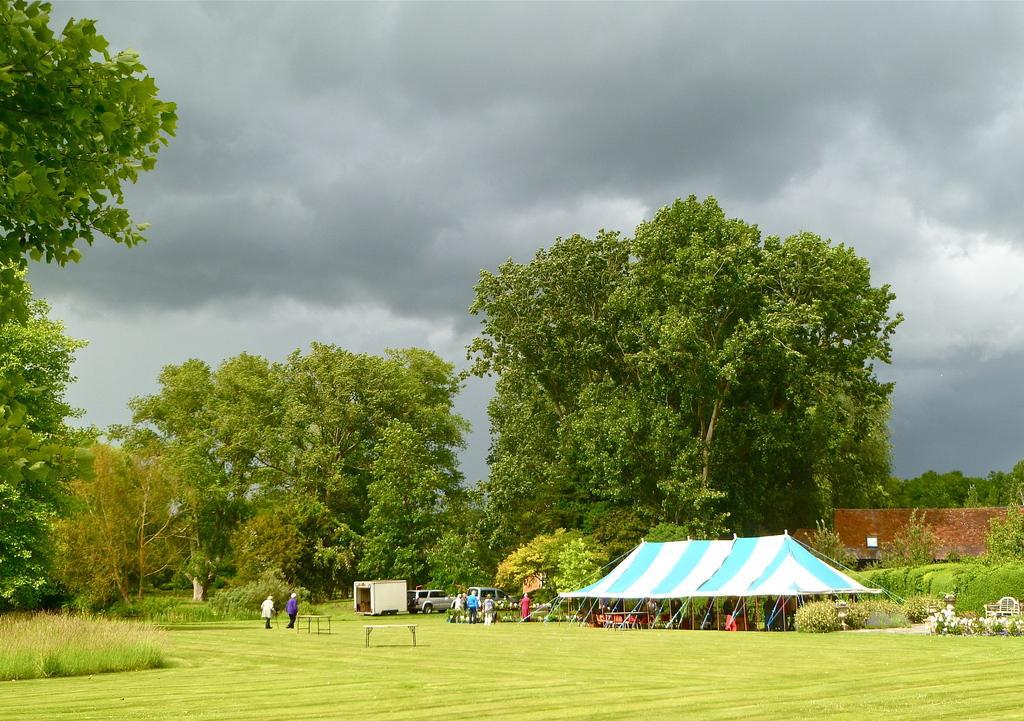Could you give a brief overview of what you see in this image? In the foreground of this image, there is a grass, plants, trees, a tent, few vehicles and persons walking on the grass. In the background, there is a building, cloud and the sky. 